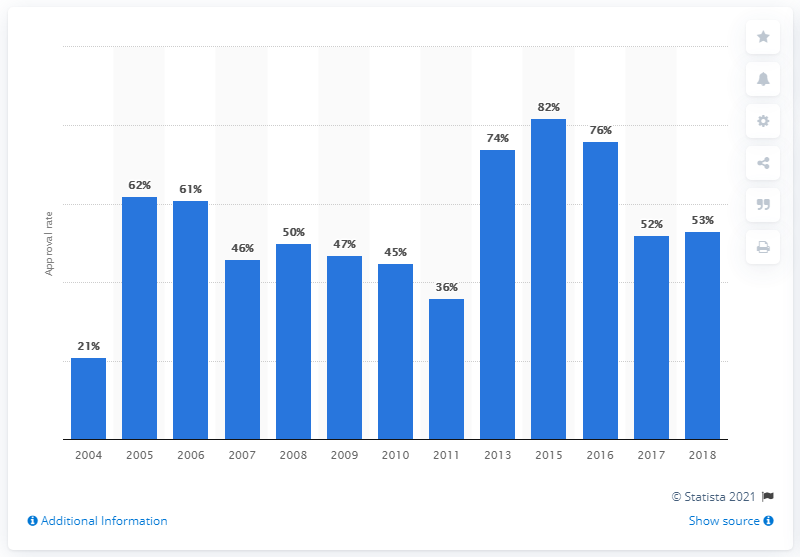Indicate a few pertinent items in this graphic. In 2018, the approval rate of Danilo Medina, the President of the Dominican Republic, was 53%. 